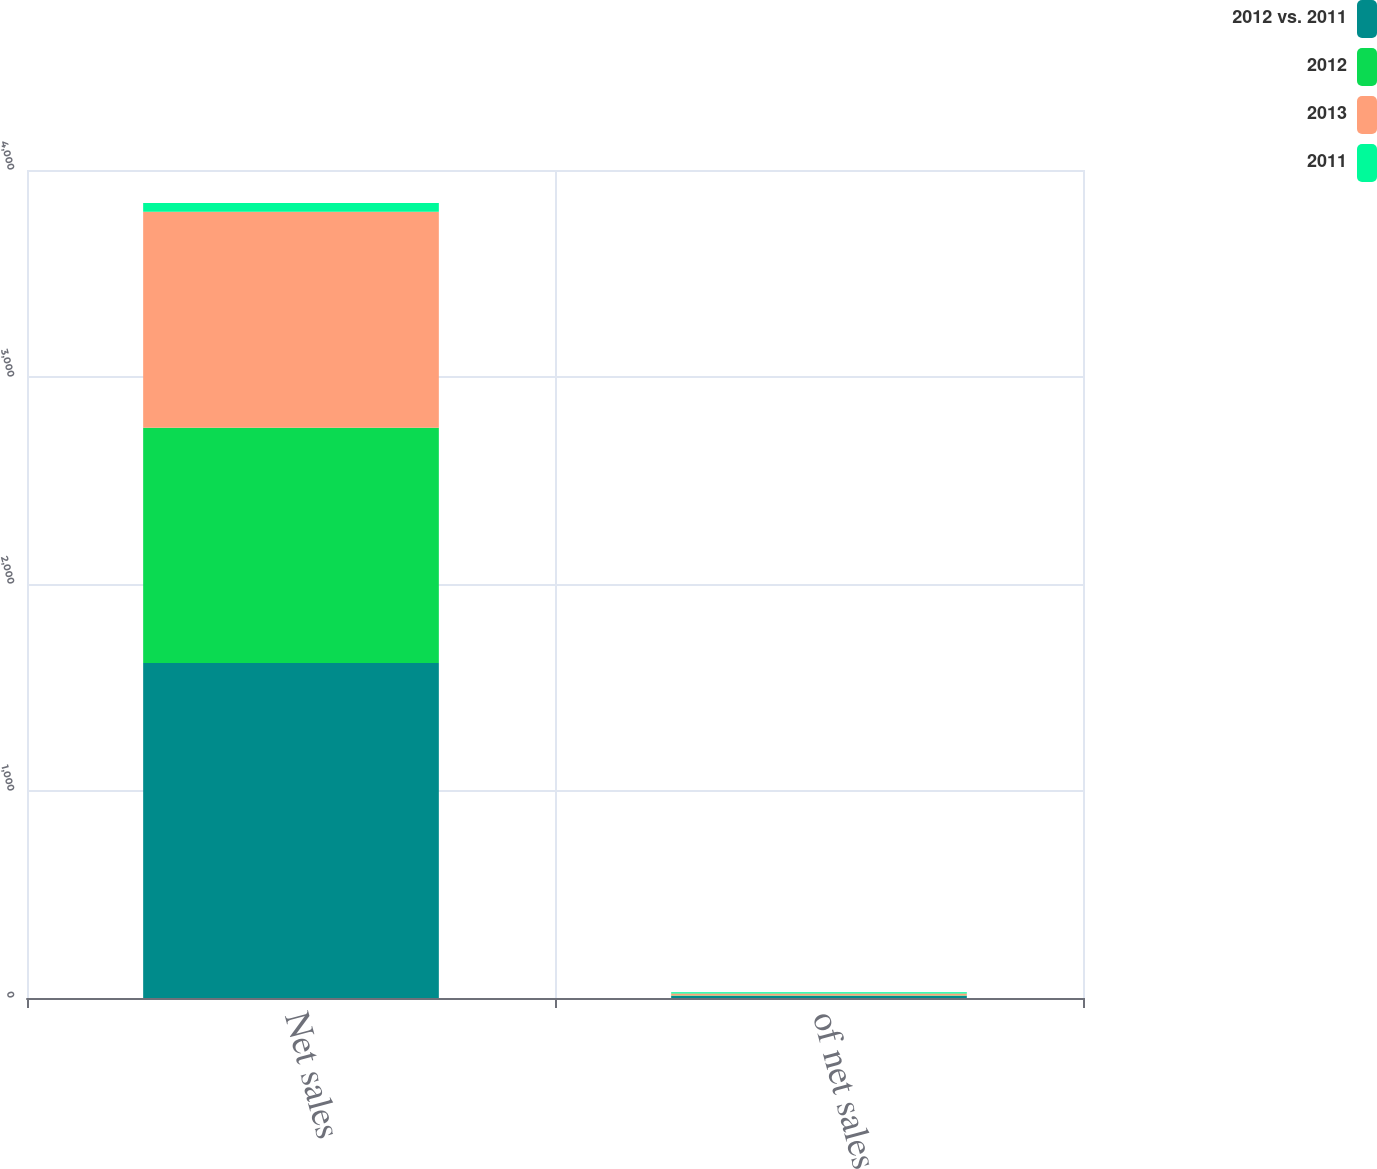Convert chart to OTSL. <chart><loc_0><loc_0><loc_500><loc_500><stacked_bar_chart><ecel><fcel>Net sales<fcel>of net sales<nl><fcel>2012 vs. 2011<fcel>1618.5<fcel>9.2<nl><fcel>2012<fcel>1136.7<fcel>3.1<nl><fcel>2013<fcel>1042.7<fcel>9.4<nl><fcel>2011<fcel>42.4<fcel>6.1<nl></chart> 